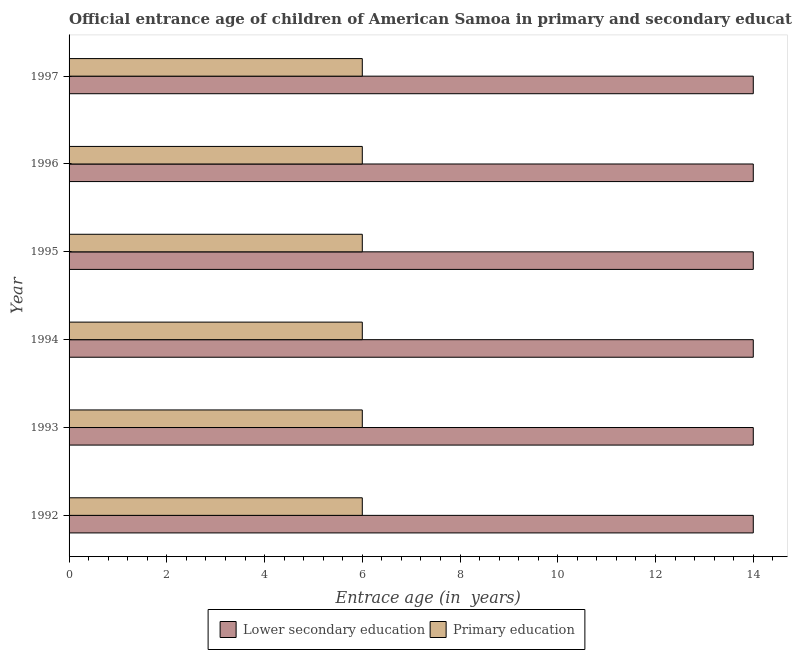How many different coloured bars are there?
Offer a very short reply. 2. Are the number of bars on each tick of the Y-axis equal?
Offer a terse response. Yes. How many bars are there on the 5th tick from the top?
Your response must be concise. 2. What is the entrance age of chiildren in primary education in 1992?
Ensure brevity in your answer.  6. Across all years, what is the maximum entrance age of children in lower secondary education?
Your response must be concise. 14. Across all years, what is the minimum entrance age of chiildren in primary education?
Offer a terse response. 6. What is the total entrance age of chiildren in primary education in the graph?
Ensure brevity in your answer.  36. What is the difference between the entrance age of children in lower secondary education in 1993 and the entrance age of chiildren in primary education in 1992?
Offer a very short reply. 8. What is the average entrance age of chiildren in primary education per year?
Provide a short and direct response. 6. In the year 1997, what is the difference between the entrance age of children in lower secondary education and entrance age of chiildren in primary education?
Make the answer very short. 8. In how many years, is the entrance age of children in lower secondary education greater than 2.8 years?
Keep it short and to the point. 6. What is the ratio of the entrance age of chiildren in primary education in 1995 to that in 1997?
Give a very brief answer. 1. Is the entrance age of chiildren in primary education in 1994 less than that in 1996?
Your response must be concise. No. Is the difference between the entrance age of chiildren in primary education in 1992 and 1997 greater than the difference between the entrance age of children in lower secondary education in 1992 and 1997?
Make the answer very short. No. Is the sum of the entrance age of chiildren in primary education in 1994 and 1996 greater than the maximum entrance age of children in lower secondary education across all years?
Give a very brief answer. No. What does the 2nd bar from the bottom in 1995 represents?
Your response must be concise. Primary education. What is the difference between two consecutive major ticks on the X-axis?
Ensure brevity in your answer.  2. Are the values on the major ticks of X-axis written in scientific E-notation?
Offer a very short reply. No. Does the graph contain any zero values?
Provide a succinct answer. No. How are the legend labels stacked?
Offer a very short reply. Horizontal. What is the title of the graph?
Offer a terse response. Official entrance age of children of American Samoa in primary and secondary education. Does "Arms exports" appear as one of the legend labels in the graph?
Provide a short and direct response. No. What is the label or title of the X-axis?
Ensure brevity in your answer.  Entrace age (in  years). What is the Entrace age (in  years) of Lower secondary education in 1992?
Offer a terse response. 14. What is the Entrace age (in  years) of Primary education in 1992?
Your answer should be compact. 6. What is the Entrace age (in  years) of Lower secondary education in 1993?
Ensure brevity in your answer.  14. What is the Entrace age (in  years) of Lower secondary education in 1994?
Your response must be concise. 14. What is the Entrace age (in  years) in Primary education in 1994?
Keep it short and to the point. 6. What is the Entrace age (in  years) of Lower secondary education in 1995?
Offer a very short reply. 14. What is the Entrace age (in  years) in Primary education in 1996?
Your response must be concise. 6. What is the Entrace age (in  years) in Lower secondary education in 1997?
Keep it short and to the point. 14. What is the Entrace age (in  years) of Primary education in 1997?
Make the answer very short. 6. Across all years, what is the maximum Entrace age (in  years) of Lower secondary education?
Give a very brief answer. 14. Across all years, what is the minimum Entrace age (in  years) in Primary education?
Keep it short and to the point. 6. What is the total Entrace age (in  years) in Primary education in the graph?
Your answer should be very brief. 36. What is the difference between the Entrace age (in  years) of Lower secondary education in 1992 and that in 1993?
Your answer should be very brief. 0. What is the difference between the Entrace age (in  years) of Primary education in 1992 and that in 1993?
Offer a terse response. 0. What is the difference between the Entrace age (in  years) in Lower secondary education in 1992 and that in 1994?
Your answer should be compact. 0. What is the difference between the Entrace age (in  years) in Primary education in 1992 and that in 1994?
Give a very brief answer. 0. What is the difference between the Entrace age (in  years) in Lower secondary education in 1992 and that in 1995?
Make the answer very short. 0. What is the difference between the Entrace age (in  years) in Primary education in 1992 and that in 1995?
Ensure brevity in your answer.  0. What is the difference between the Entrace age (in  years) of Lower secondary education in 1992 and that in 1996?
Your answer should be compact. 0. What is the difference between the Entrace age (in  years) of Primary education in 1992 and that in 1997?
Provide a short and direct response. 0. What is the difference between the Entrace age (in  years) of Lower secondary education in 1993 and that in 1994?
Give a very brief answer. 0. What is the difference between the Entrace age (in  years) of Lower secondary education in 1993 and that in 1995?
Offer a terse response. 0. What is the difference between the Entrace age (in  years) in Primary education in 1993 and that in 1995?
Give a very brief answer. 0. What is the difference between the Entrace age (in  years) of Lower secondary education in 1993 and that in 1996?
Give a very brief answer. 0. What is the difference between the Entrace age (in  years) in Lower secondary education in 1994 and that in 1995?
Provide a short and direct response. 0. What is the difference between the Entrace age (in  years) of Primary education in 1994 and that in 1995?
Provide a succinct answer. 0. What is the difference between the Entrace age (in  years) in Primary education in 1994 and that in 1996?
Give a very brief answer. 0. What is the difference between the Entrace age (in  years) of Lower secondary education in 1995 and that in 1997?
Provide a succinct answer. 0. What is the difference between the Entrace age (in  years) in Primary education in 1995 and that in 1997?
Offer a terse response. 0. What is the difference between the Entrace age (in  years) of Lower secondary education in 1996 and that in 1997?
Give a very brief answer. 0. What is the difference between the Entrace age (in  years) in Lower secondary education in 1992 and the Entrace age (in  years) in Primary education in 1997?
Provide a succinct answer. 8. What is the difference between the Entrace age (in  years) of Lower secondary education in 1993 and the Entrace age (in  years) of Primary education in 1994?
Provide a succinct answer. 8. What is the difference between the Entrace age (in  years) in Lower secondary education in 1993 and the Entrace age (in  years) in Primary education in 1996?
Offer a terse response. 8. What is the difference between the Entrace age (in  years) of Lower secondary education in 1993 and the Entrace age (in  years) of Primary education in 1997?
Ensure brevity in your answer.  8. What is the difference between the Entrace age (in  years) in Lower secondary education in 1994 and the Entrace age (in  years) in Primary education in 1995?
Ensure brevity in your answer.  8. What is the difference between the Entrace age (in  years) in Lower secondary education in 1994 and the Entrace age (in  years) in Primary education in 1996?
Offer a terse response. 8. What is the difference between the Entrace age (in  years) of Lower secondary education in 1994 and the Entrace age (in  years) of Primary education in 1997?
Your response must be concise. 8. What is the difference between the Entrace age (in  years) of Lower secondary education in 1995 and the Entrace age (in  years) of Primary education in 1996?
Offer a terse response. 8. What is the difference between the Entrace age (in  years) of Lower secondary education in 1995 and the Entrace age (in  years) of Primary education in 1997?
Give a very brief answer. 8. What is the difference between the Entrace age (in  years) in Lower secondary education in 1996 and the Entrace age (in  years) in Primary education in 1997?
Your response must be concise. 8. What is the average Entrace age (in  years) in Lower secondary education per year?
Your answer should be compact. 14. In the year 1992, what is the difference between the Entrace age (in  years) of Lower secondary education and Entrace age (in  years) of Primary education?
Provide a succinct answer. 8. In the year 1994, what is the difference between the Entrace age (in  years) of Lower secondary education and Entrace age (in  years) of Primary education?
Your answer should be compact. 8. In the year 1995, what is the difference between the Entrace age (in  years) in Lower secondary education and Entrace age (in  years) in Primary education?
Make the answer very short. 8. In the year 1996, what is the difference between the Entrace age (in  years) of Lower secondary education and Entrace age (in  years) of Primary education?
Your answer should be very brief. 8. In the year 1997, what is the difference between the Entrace age (in  years) in Lower secondary education and Entrace age (in  years) in Primary education?
Your answer should be very brief. 8. What is the ratio of the Entrace age (in  years) in Primary education in 1992 to that in 1994?
Give a very brief answer. 1. What is the ratio of the Entrace age (in  years) in Primary education in 1992 to that in 1995?
Offer a terse response. 1. What is the ratio of the Entrace age (in  years) in Lower secondary education in 1992 to that in 1997?
Your answer should be compact. 1. What is the ratio of the Entrace age (in  years) of Primary education in 1992 to that in 1997?
Offer a very short reply. 1. What is the ratio of the Entrace age (in  years) of Primary education in 1993 to that in 1994?
Your response must be concise. 1. What is the ratio of the Entrace age (in  years) of Lower secondary education in 1993 to that in 1996?
Offer a terse response. 1. What is the ratio of the Entrace age (in  years) in Lower secondary education in 1993 to that in 1997?
Provide a succinct answer. 1. What is the ratio of the Entrace age (in  years) in Primary education in 1993 to that in 1997?
Offer a very short reply. 1. What is the ratio of the Entrace age (in  years) in Primary education in 1994 to that in 1995?
Ensure brevity in your answer.  1. What is the ratio of the Entrace age (in  years) in Primary education in 1994 to that in 1996?
Your answer should be compact. 1. What is the ratio of the Entrace age (in  years) in Primary education in 1994 to that in 1997?
Ensure brevity in your answer.  1. What is the ratio of the Entrace age (in  years) in Lower secondary education in 1995 to that in 1996?
Your answer should be compact. 1. What is the ratio of the Entrace age (in  years) in Primary education in 1995 to that in 1996?
Provide a short and direct response. 1. What is the ratio of the Entrace age (in  years) of Lower secondary education in 1996 to that in 1997?
Offer a very short reply. 1. What is the ratio of the Entrace age (in  years) in Primary education in 1996 to that in 1997?
Give a very brief answer. 1. What is the difference between the highest and the second highest Entrace age (in  years) of Primary education?
Offer a very short reply. 0. 